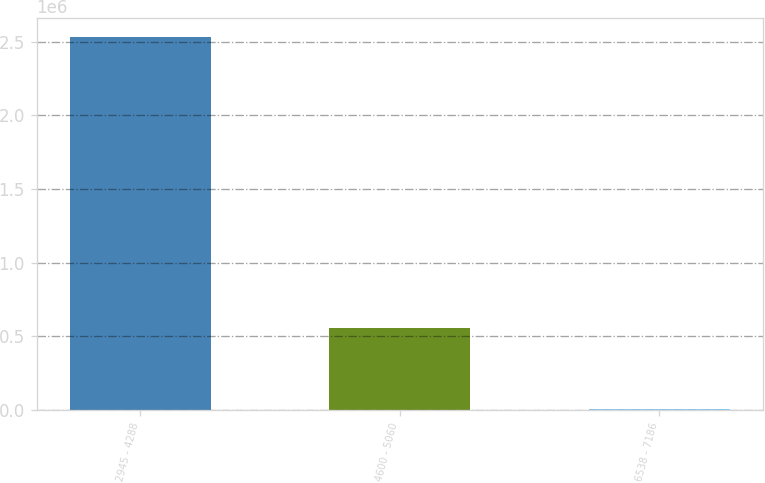<chart> <loc_0><loc_0><loc_500><loc_500><bar_chart><fcel>2945 - 4288<fcel>4600 - 5060<fcel>6538 - 7186<nl><fcel>2.53572e+06<fcel>552000<fcel>2122<nl></chart> 